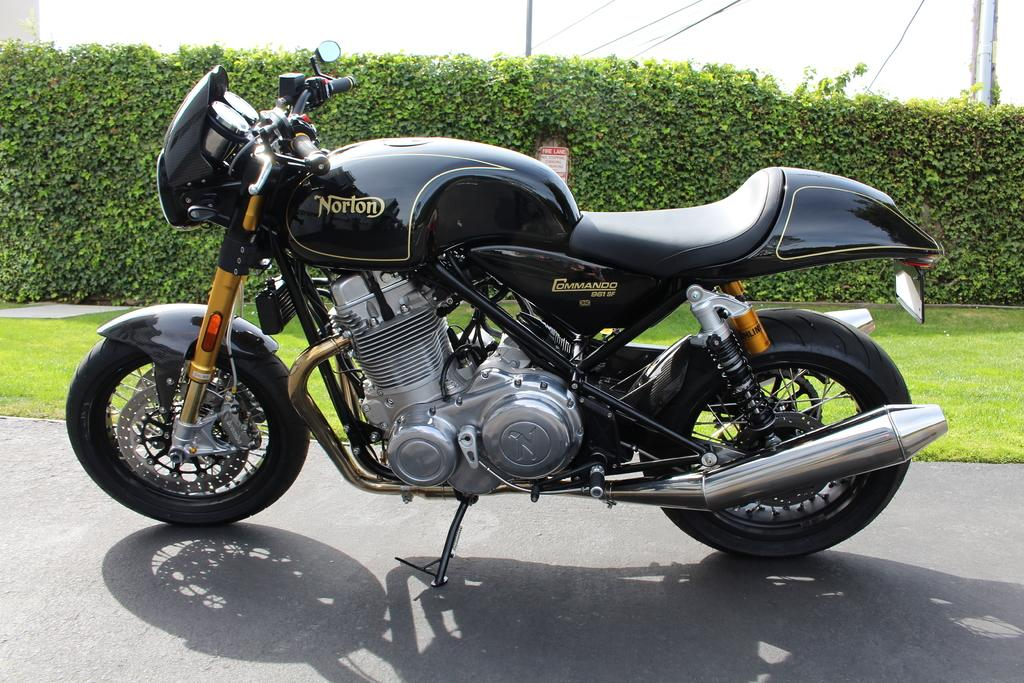What type of vehicle is in the image? There is a motorbike in the image. What colors can be seen on the motorbike? The motorbike is silver, black, and gold in color. Where is the motorbike located? The motorbike is on the road. What can be seen in the background of the image? There is grass, plants, a metal pole, wires, and the sky visible in the background of the image. What day of the week is depicted in the image? The image does not depict a specific day of the week; it only shows a motorbike on the road and the background elements. 